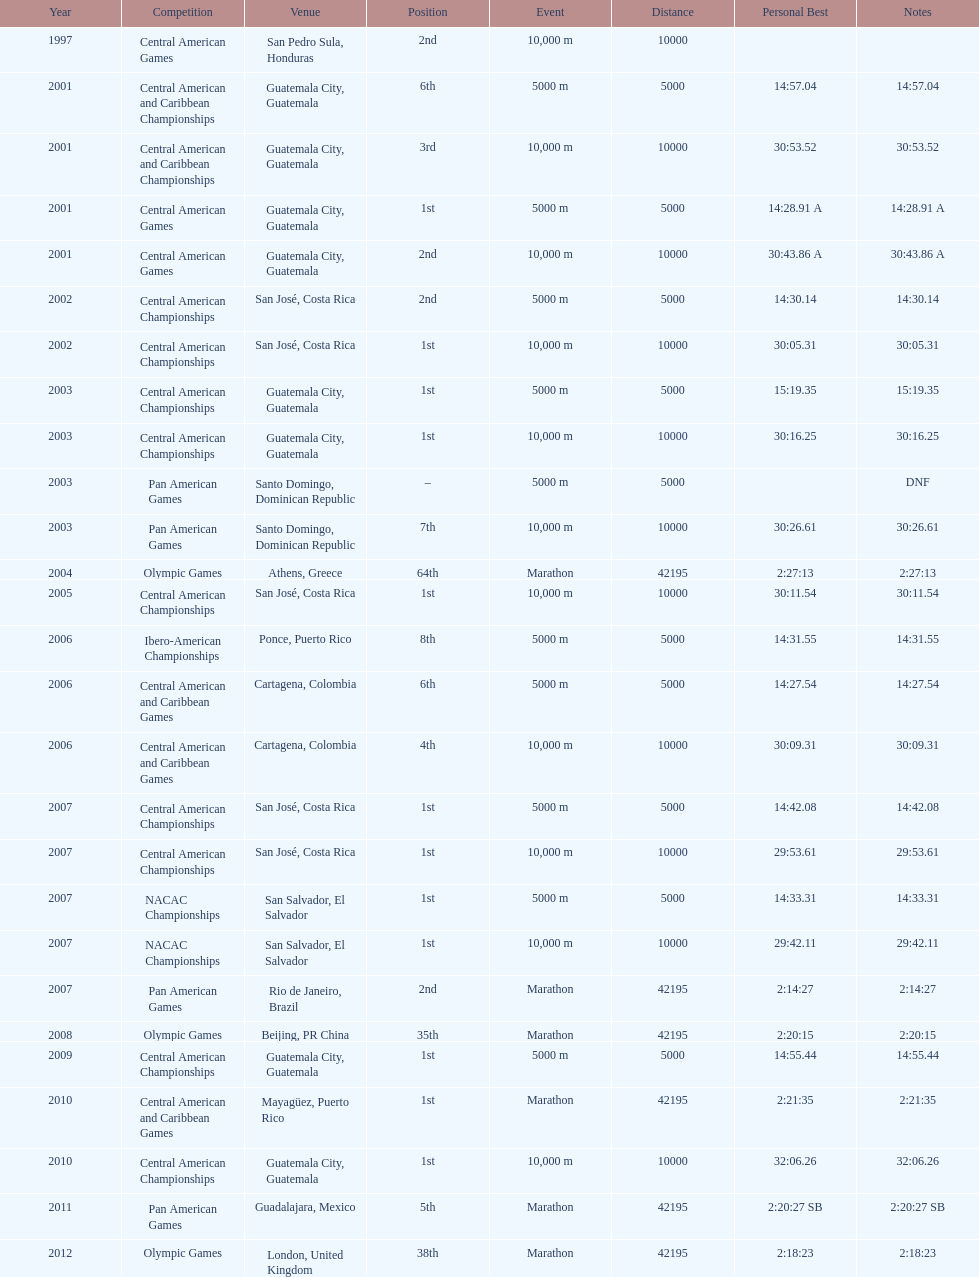Tell me the number of times they competed in guatamala. 5. 